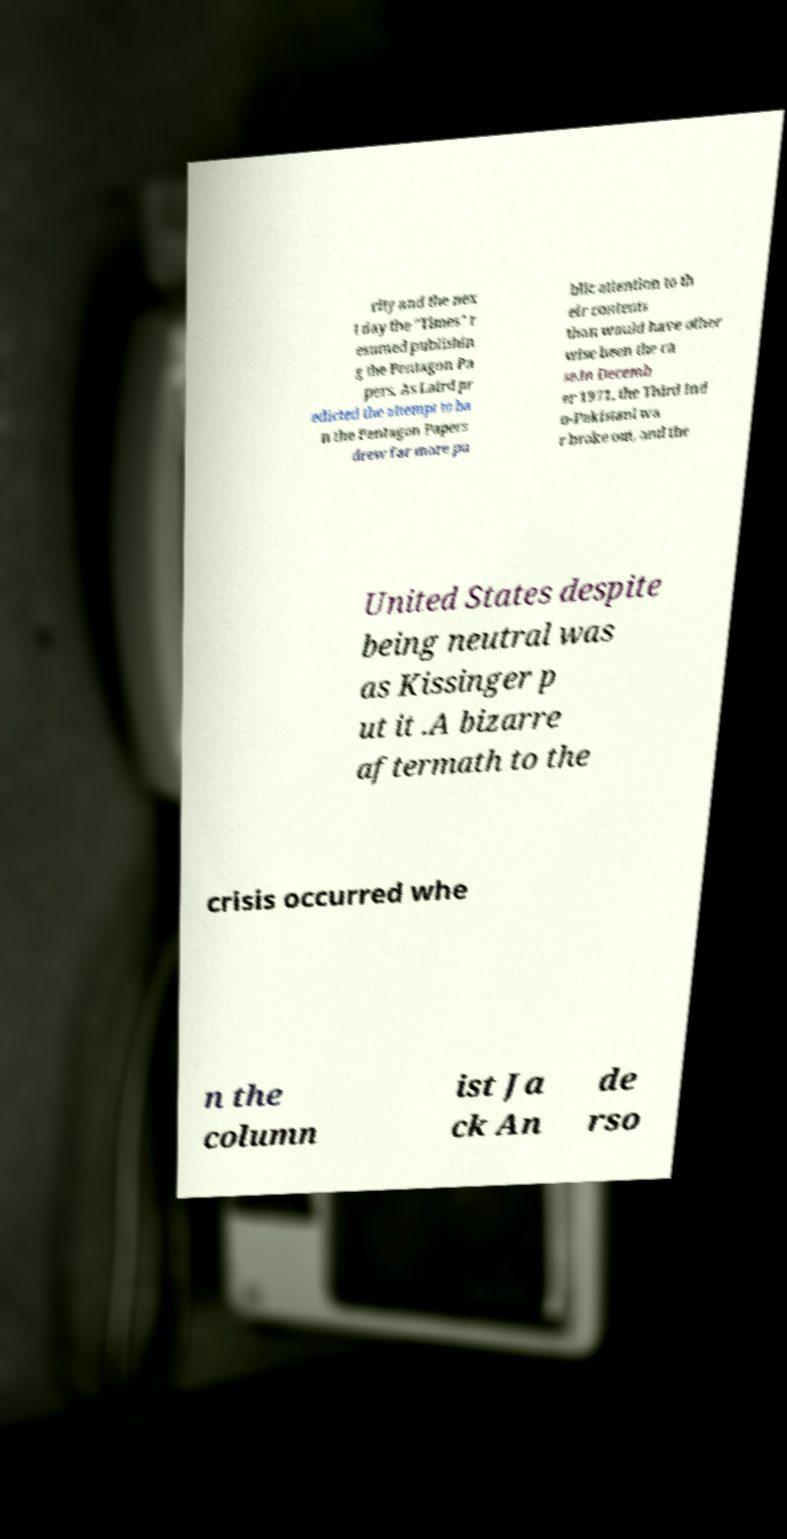Could you extract and type out the text from this image? rity and the nex t day the "Times" r esumed publishin g the Pentagon Pa pers. As Laird pr edicted the attempt to ba n the Pentagon Papers drew far more pu blic attention to th eir contents than would have other wise been the ca se.In Decemb er 1971, the Third Ind o-Pakistani wa r broke out, and the United States despite being neutral was as Kissinger p ut it .A bizarre aftermath to the crisis occurred whe n the column ist Ja ck An de rso 